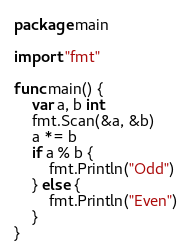Convert code to text. <code><loc_0><loc_0><loc_500><loc_500><_Go_>package main

import "fmt"

func main() {
	var a, b int
	fmt.Scan(&a, &b)
	a *= b
	if a % b {
		fmt.Println("Odd")
	} else {
		fmt.Println("Even")
	}
}
</code> 